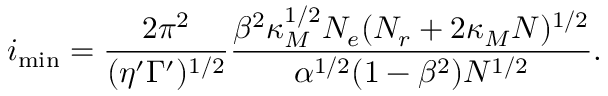Convert formula to latex. <formula><loc_0><loc_0><loc_500><loc_500>i _ { \min } = \frac { 2 \pi ^ { 2 } } { ( \eta ^ { \prime } \Gamma ^ { \prime } ) ^ { 1 / 2 } } \frac { \beta ^ { 2 } \kappa _ { M } ^ { 1 / 2 } N _ { e } ( N _ { r } + 2 \kappa _ { M } N ) ^ { 1 / 2 } } { \alpha ^ { 1 / 2 } ( 1 - \beta ^ { 2 } ) N ^ { 1 / 2 } } .</formula> 